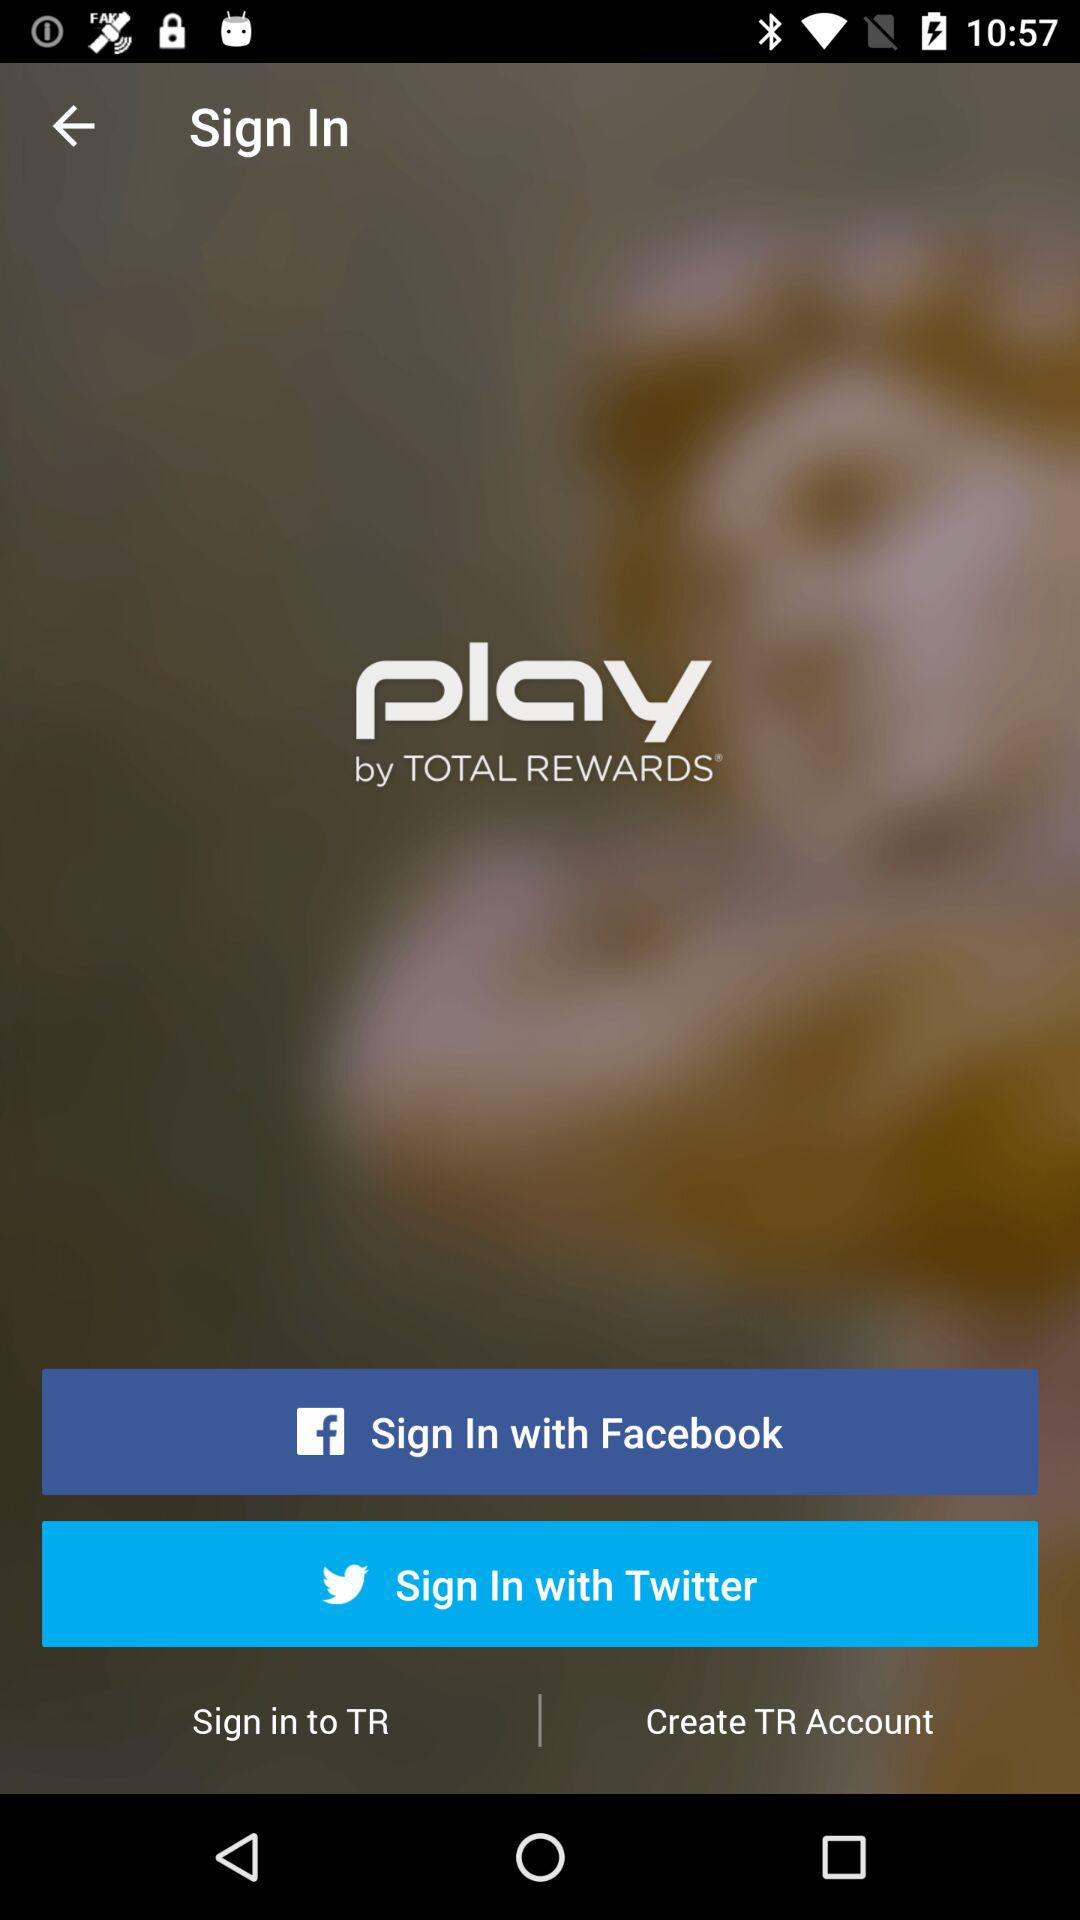What is the user's email address?
When the provided information is insufficient, respond with <no answer>. <no answer> 